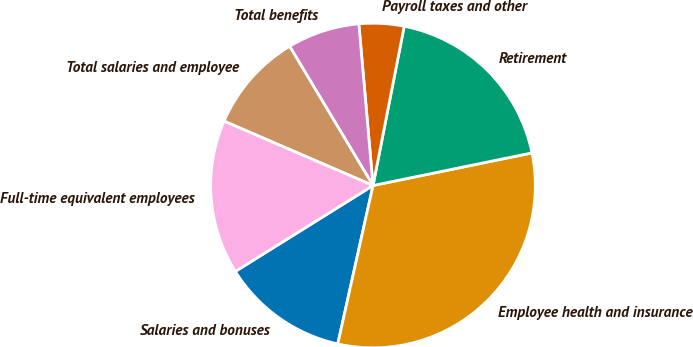Convert chart to OTSL. <chart><loc_0><loc_0><loc_500><loc_500><pie_chart><fcel>Salaries and bonuses<fcel>Employee health and insurance<fcel>Retirement<fcel>Payroll taxes and other<fcel>Total benefits<fcel>Total salaries and employee<fcel>Full-time equivalent employees<nl><fcel>12.64%<fcel>31.71%<fcel>18.7%<fcel>4.47%<fcel>7.2%<fcel>9.92%<fcel>15.37%<nl></chart> 